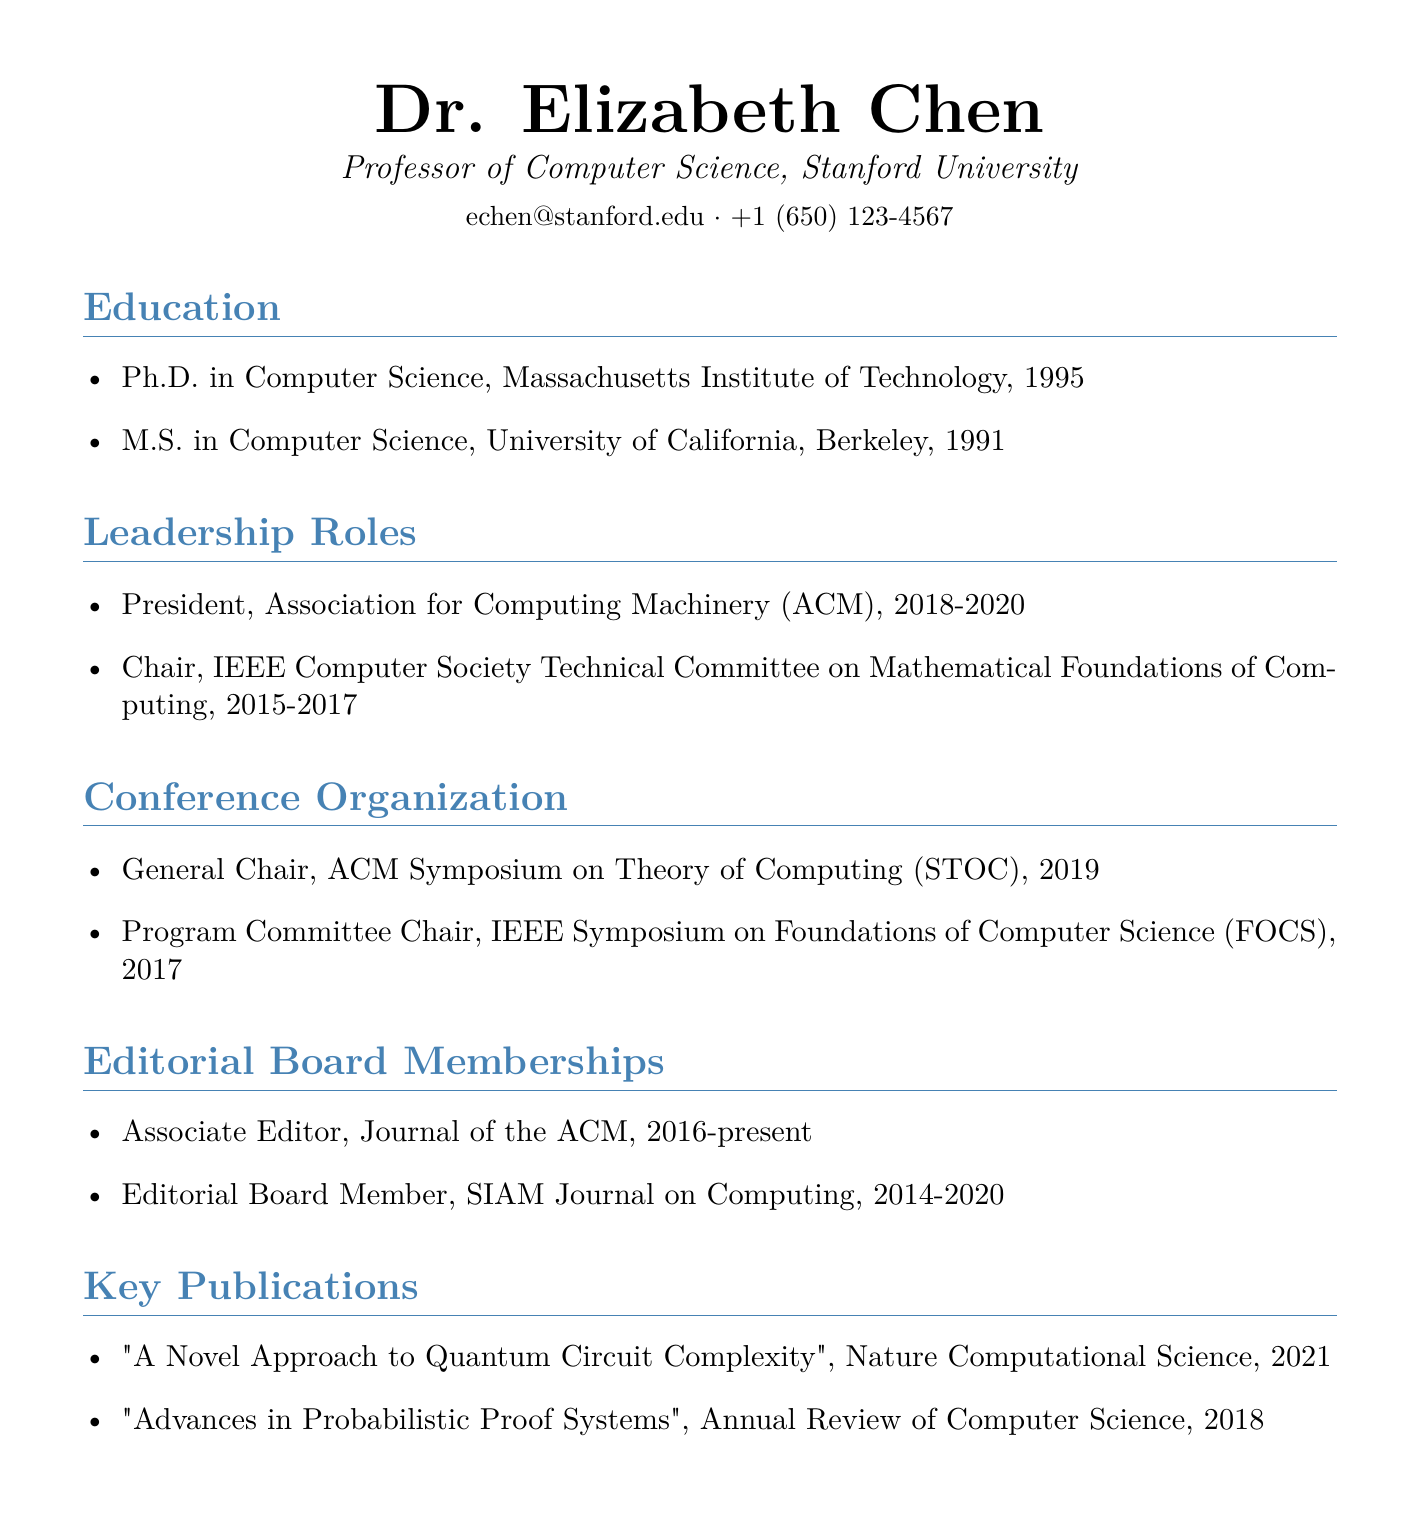What is the name of the professor? The document provides the full name of the professor at the top, which is Dr. Elizabeth Chen.
Answer: Dr. Elizabeth Chen Which university is the professor affiliated with? The document lists the professor's affiliation as Stanford University.
Answer: Stanford University What role did she hold at the ACM from 2018 to 2020? The document states she was the President of the Association for Computing Machinery (ACM) during that time.
Answer: President In which year did she serve as the General Chair for the ACM Symposium on Theory of Computing? The document specifies that she served in this role in 2019.
Answer: 2019 What is the title of her publication in 2021? The document lists a publication titled "A Novel Approach to Quantum Circuit Complexity" from that year.
Answer: A Novel Approach to Quantum Circuit Complexity Which journal does she currently serve as an Associate Editor? The document indicates she is an Associate Editor for the Journal of the ACM.
Answer: Journal of the ACM How long was she a board member for the SIAM Journal on Computing? The document states her membership lasted from 2014 to 2020, which is 6 years.
Answer: 6 years What position did she hold in the IEEE Computer Society from 2015 to 2017? The document specifies that she was the Chair of the IEEE Computer Society Technical Committee on Mathematical Foundations of Computing.
Answer: Chair What type of document is this? The overall structure and content of the document indicate that it is a Curriculum Vitae.
Answer: Curriculum Vitae 